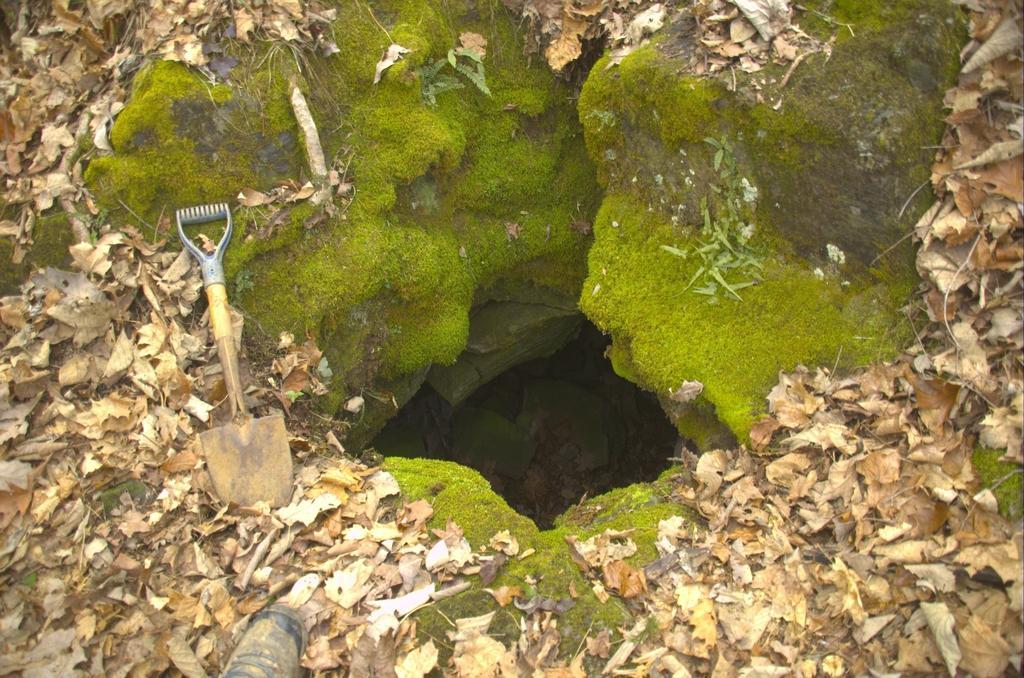In one or two sentences, can you explain what this image depicts? In this picture we can see a pit, beside to the pit we can find a digging tool, fungus and leaves. 